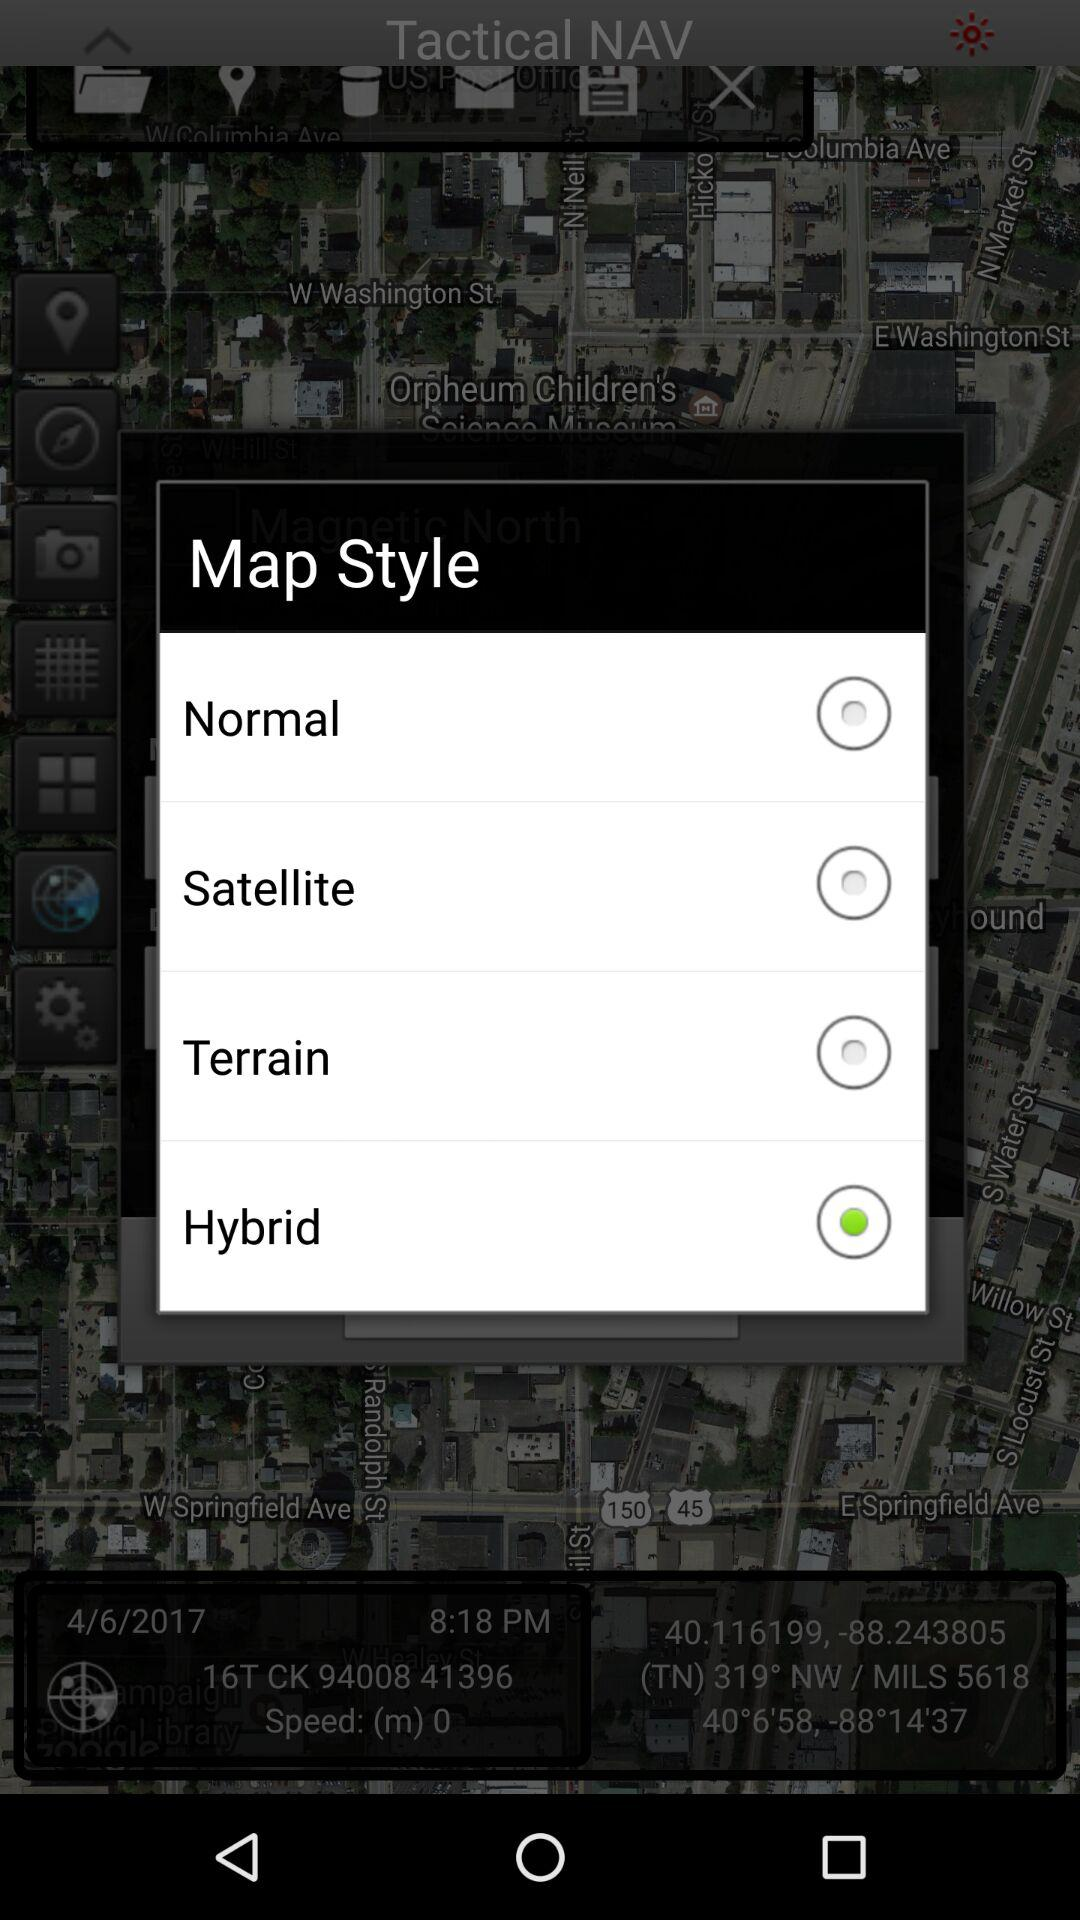What is the given time? The given time is 8:18 PM. 